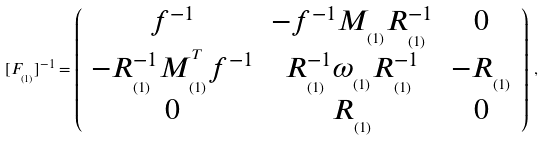<formula> <loc_0><loc_0><loc_500><loc_500>[ F _ { _ { ( 1 ) } } ] ^ { - 1 } = \left ( \begin{array} { c c c } f ^ { - 1 } & - f ^ { - 1 } M _ { _ { ( 1 ) } } R _ { _ { ( 1 ) } } ^ { - 1 } & 0 \\ - R _ { _ { ( 1 ) } } ^ { - 1 } M _ { _ { ( 1 ) } } ^ { ^ { T } } f ^ { - 1 } & R _ { _ { ( 1 ) } } ^ { - 1 } \omega _ { _ { ( 1 ) } } R _ { _ { ( 1 ) } } ^ { - 1 } & - R _ { _ { ( 1 ) } } \\ 0 & R _ { _ { ( 1 ) } } & 0 \end{array} \right ) \, ,</formula> 